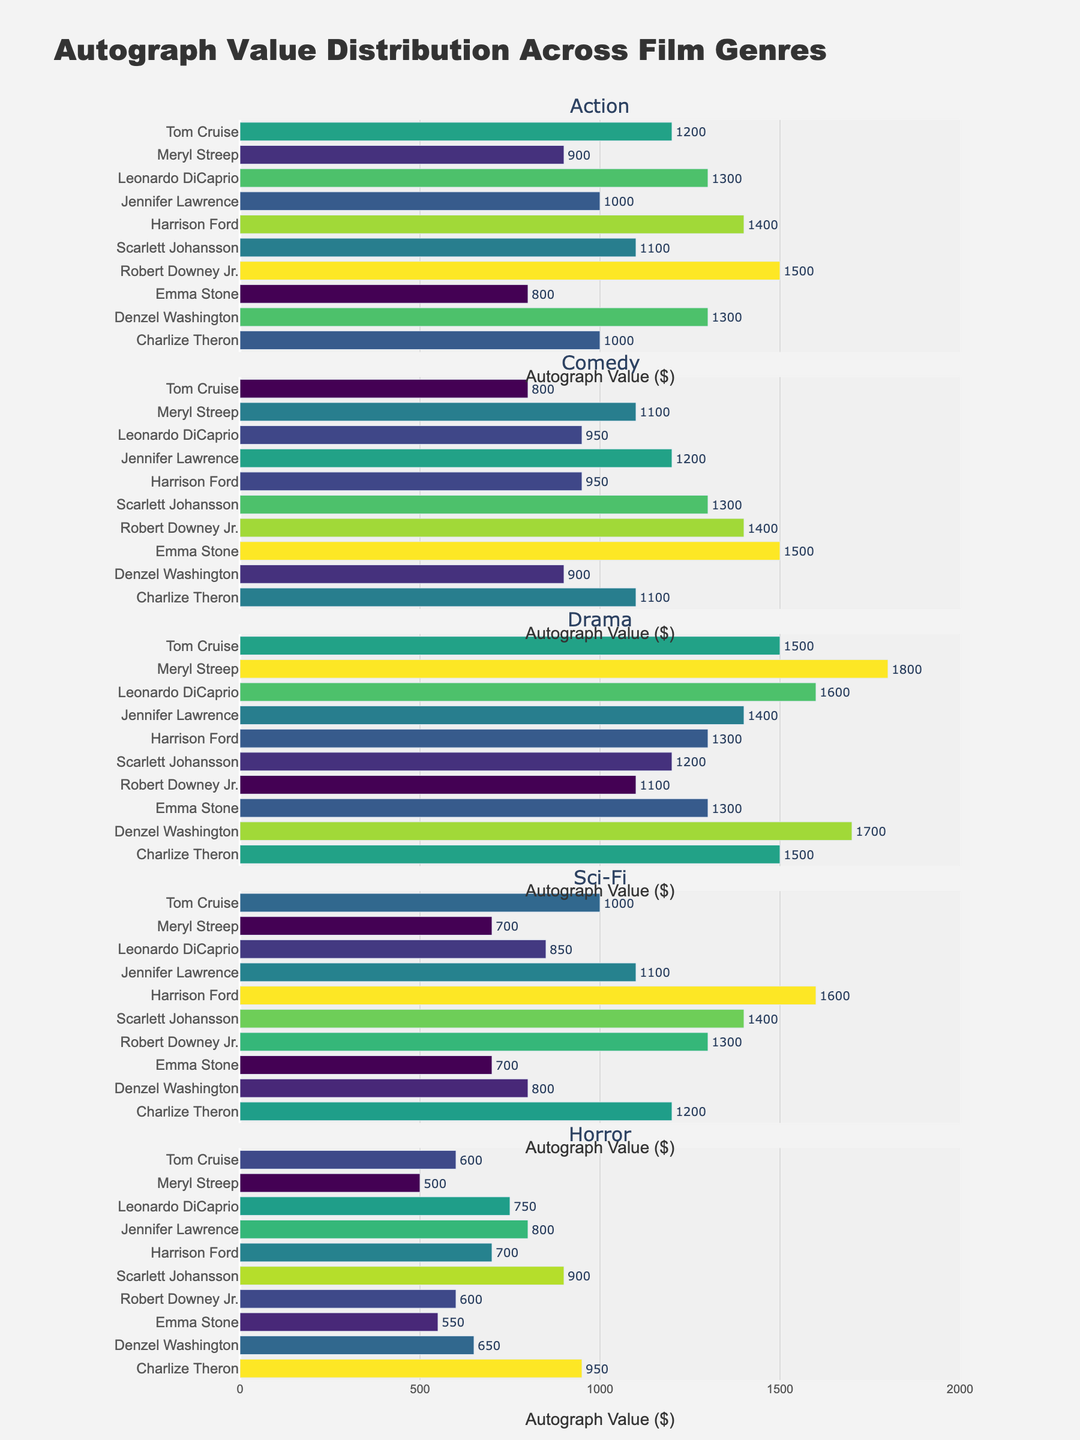What's the highest Song Structure Complexity score observed over time? The line plot in the top-left subplot shows that the highest Song Structure Complexity score is around 9, occurring in the year 2002 for the album "Untouchables."
Answer: 9 Which album has the highest Electronic Elements usage and what percentage is it? The bar chart in the top-right subplot highlights that "The Path of Totality" album has the highest Electronic Elements usage percentage at 80%.
Answer: The Path of Totality, 80% How many albums feature Drop A guitar tuning and what percentage of the total albums does this represent? The pie chart in the bottom-right subplot indicates there are 5 albums with Drop A guitar tuning. Out of 14 albums, this represents approximately (5/14) * 100% ≈ 35.7%.
Answer: 5, 35.7% Which year shows the lowest score for Song Structure Complexity and what is that score? The line plot in the top-left subplot shows that the lowest Song Structure Complexity score is 4 in the year 2011 for "The Path of Totality" album.
Answer: 4 As Electronic Elements usage increased, what trend can you observe in Song Structure Complexity? Comparing the bar chart (Electronic Elements usage) to the line plot (Song Structure Complexity), an increasing trend in Electronic Elements usage generally correlates to a decreasing trend in Song Structure Complexity. For example, the highest usage of Electronic Elements (80% in 2011) coincides with the lowest Song Structure Complexity (score of 4).
Answer: Increased Electronic Elements, Decreased Complexity Between 2010 and 2013, how did the Number of Breakdowns change compared to Vocal Experimentation? The scatter plot in the bottom-left subplot shows the Number of Breakdowns remains constant at around 4, while Vocal Experimentation slightly decreased from around 6 to 7. This shows a slight increase in Vocal Experimentation for 2013's "The Paradigm Shift."
Answer: Constant Breakdowns, Slight increase in Vocal Experimentation Which album experienced the greatest increase in Electronic Elements usage compared to the previous album? The bar chart shows a substantial increase in Electronic Elements from "Korn III: Remember Who You Are" to "The Path of Totality," moving from 10% to 80%. This album experienced the greatest increase.
Answer: The Path of Totality How does the score for Vocal Experimentation correlate with the release year? By observing the scatter plot in the bottom-left, there is generally an upward trend in Vocal Experimentation scores as the release year progresses, suggesting increasing experimentation in vocals in more recent years.
Answer: Positive Correlation What overall pattern do you see in the usage of Drop A tuning over the years? The pie chart and line plot together reveal that Drop A tuning began appearing from 2002 onwards and has been used continuously in subsequent albums with few exceptions, indicating a trend towards lower tuning in later years.
Answer: Increased use over time from 2002 What combination of Number of Breakdowns and Vocal Experimentation score is most common? The scatter plot indicates that the most common combination is approximately 4 breakdowns with a Vocal Experimentation score ranging around 7 to 8, showing a clustering in this range.
Answer: 4 Breakdowns, Vocal Experimentation 7-8 